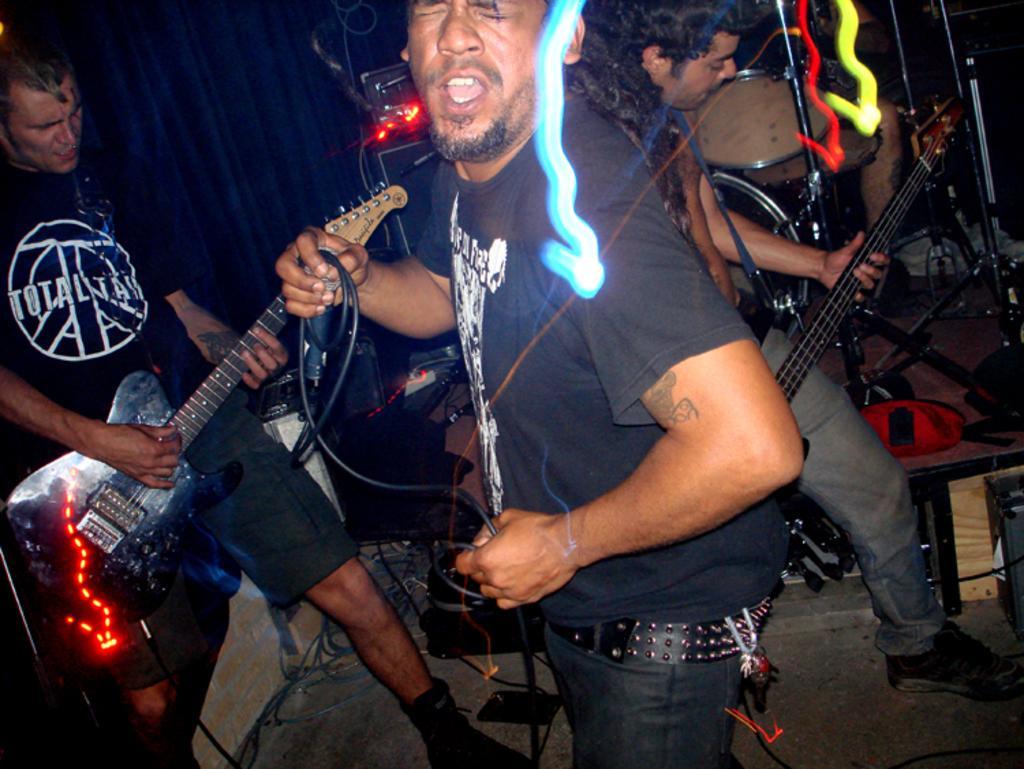Describe this image in one or two sentences. In this picture there are three men who are playing musical instruments ,two of them are playing a guitar and a guy is singing. In the background we can find various musical instruments , there is blue curtain in the background. 